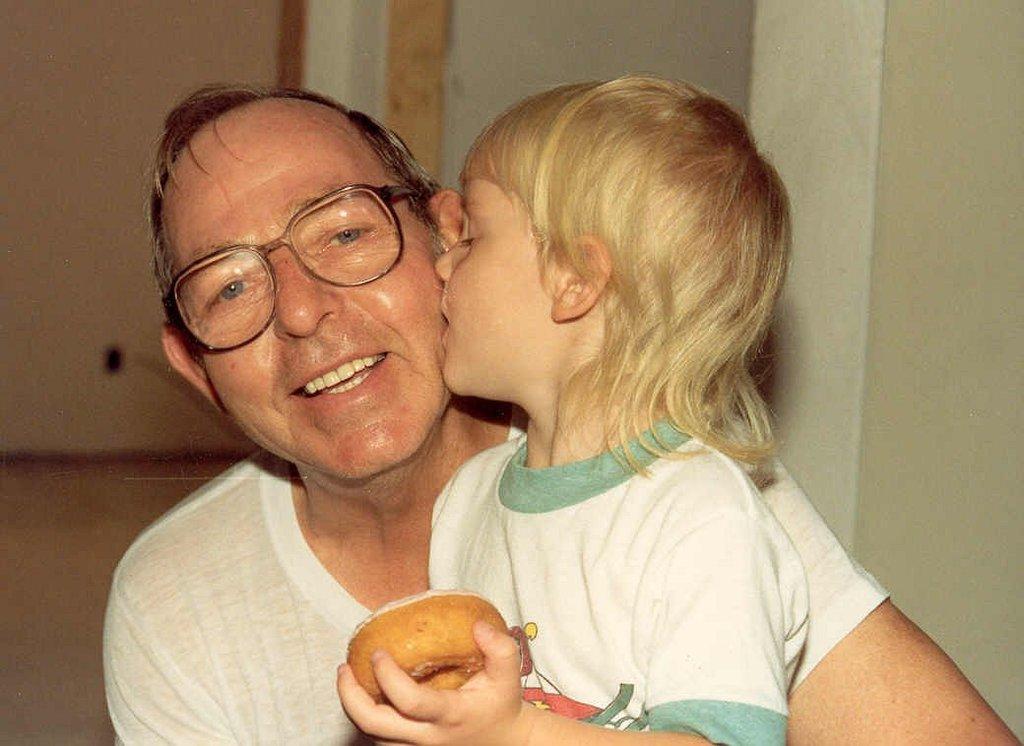Describe this image in one or two sentences. In this image there is a person holding a kid , and a kid is holding a doughnut , and at the background there is wall. 